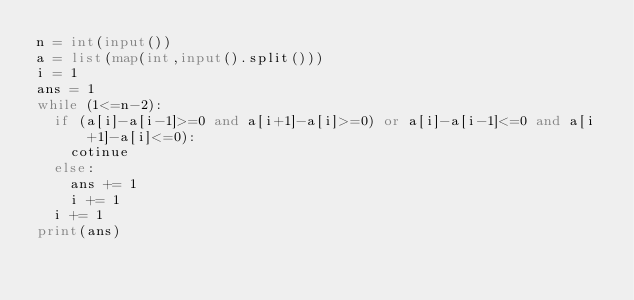Convert code to text. <code><loc_0><loc_0><loc_500><loc_500><_Python_>n = int(input())
a = list(map(int,input().split()))
i = 1
ans = 1
while (1<=n-2):
  if (a[i]-a[i-1]>=0 and a[i+1]-a[i]>=0) or a[i]-a[i-1]<=0 and a[i+1]-a[i]<=0):
    cotinue
  else:
    ans += 1
    i += 1
  i += 1
print(ans)</code> 